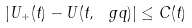<formula> <loc_0><loc_0><loc_500><loc_500>| U _ { + } ( t ) - U ( t , \ g q ) | \leq C ( t )</formula> 